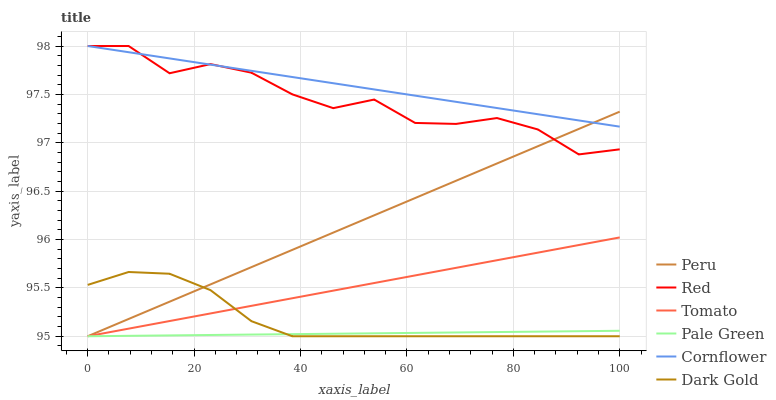Does Pale Green have the minimum area under the curve?
Answer yes or no. Yes. Does Cornflower have the maximum area under the curve?
Answer yes or no. Yes. Does Dark Gold have the minimum area under the curve?
Answer yes or no. No. Does Dark Gold have the maximum area under the curve?
Answer yes or no. No. Is Pale Green the smoothest?
Answer yes or no. Yes. Is Red the roughest?
Answer yes or no. Yes. Is Cornflower the smoothest?
Answer yes or no. No. Is Cornflower the roughest?
Answer yes or no. No. Does Tomato have the lowest value?
Answer yes or no. Yes. Does Cornflower have the lowest value?
Answer yes or no. No. Does Red have the highest value?
Answer yes or no. Yes. Does Dark Gold have the highest value?
Answer yes or no. No. Is Tomato less than Cornflower?
Answer yes or no. Yes. Is Red greater than Dark Gold?
Answer yes or no. Yes. Does Peru intersect Dark Gold?
Answer yes or no. Yes. Is Peru less than Dark Gold?
Answer yes or no. No. Is Peru greater than Dark Gold?
Answer yes or no. No. Does Tomato intersect Cornflower?
Answer yes or no. No. 